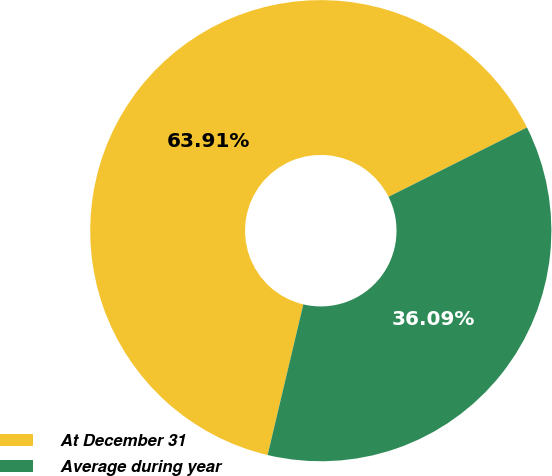Convert chart to OTSL. <chart><loc_0><loc_0><loc_500><loc_500><pie_chart><fcel>At December 31<fcel>Average during year<nl><fcel>63.91%<fcel>36.09%<nl></chart> 